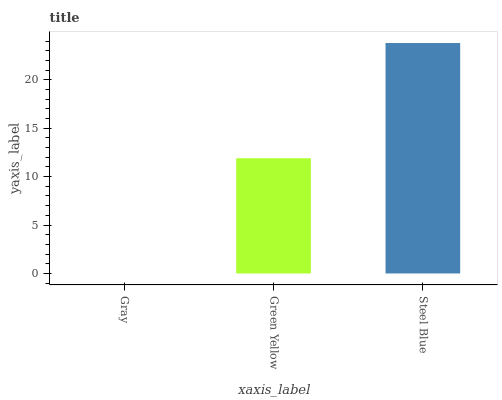Is Gray the minimum?
Answer yes or no. Yes. Is Steel Blue the maximum?
Answer yes or no. Yes. Is Green Yellow the minimum?
Answer yes or no. No. Is Green Yellow the maximum?
Answer yes or no. No. Is Green Yellow greater than Gray?
Answer yes or no. Yes. Is Gray less than Green Yellow?
Answer yes or no. Yes. Is Gray greater than Green Yellow?
Answer yes or no. No. Is Green Yellow less than Gray?
Answer yes or no. No. Is Green Yellow the high median?
Answer yes or no. Yes. Is Green Yellow the low median?
Answer yes or no. Yes. Is Gray the high median?
Answer yes or no. No. Is Gray the low median?
Answer yes or no. No. 